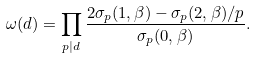<formula> <loc_0><loc_0><loc_500><loc_500>\omega ( d ) = \prod _ { p | d } \frac { 2 \sigma _ { p } ( 1 , \beta ) - \sigma _ { p } ( 2 , \beta ) / p } { \sigma _ { p } ( 0 , \beta ) } .</formula> 